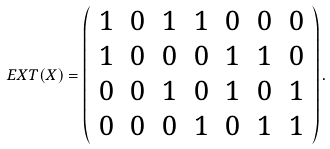<formula> <loc_0><loc_0><loc_500><loc_500>E X T ( X ) = \left ( \begin{array} { c c c c c c c } 1 & 0 & 1 & 1 & 0 & 0 & 0 \\ 1 & 0 & 0 & 0 & 1 & 1 & 0 \\ 0 & 0 & 1 & 0 & 1 & 0 & 1 \\ 0 & 0 & 0 & 1 & 0 & 1 & 1 \end{array} \right ) .</formula> 